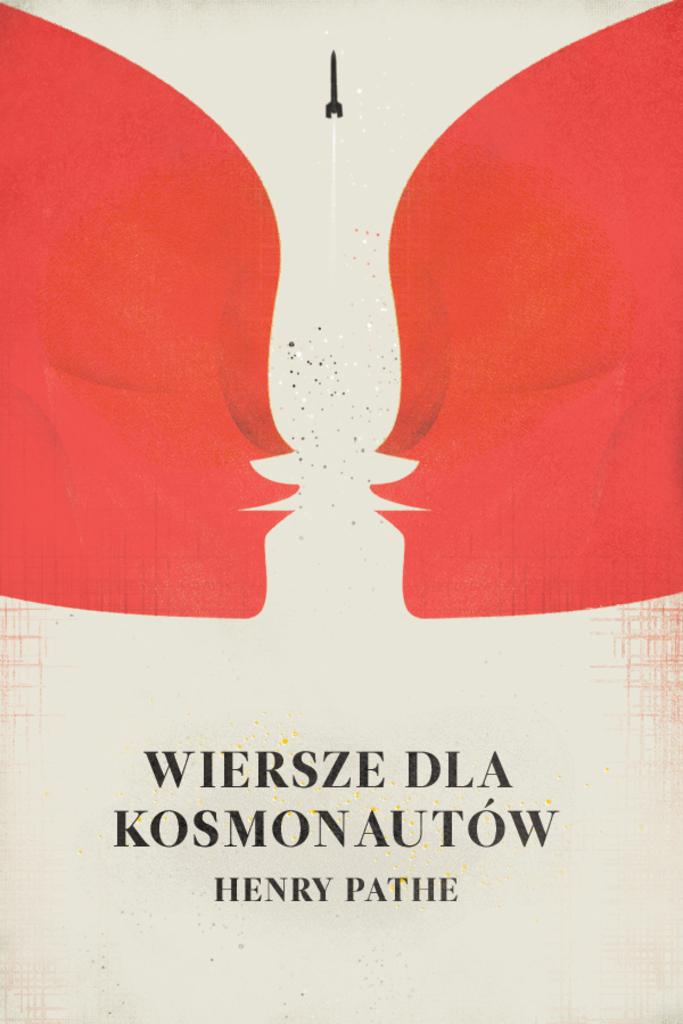What colors are present in the images on both sides of the picture? The images on both sides of the picture are red in color. What is present between the two red color images? There is glitter in between the red color images. Is there anything at the bottom of the picture? Yes, there is an object or image at the bottom of the picture. What type of steel is used to create the prose in the image? There is no steel or prose present in the image; it features red color images with glitter in between. How many people are talking in the image? There are no people present in the image, so it is not possible to determine how many are talking. 